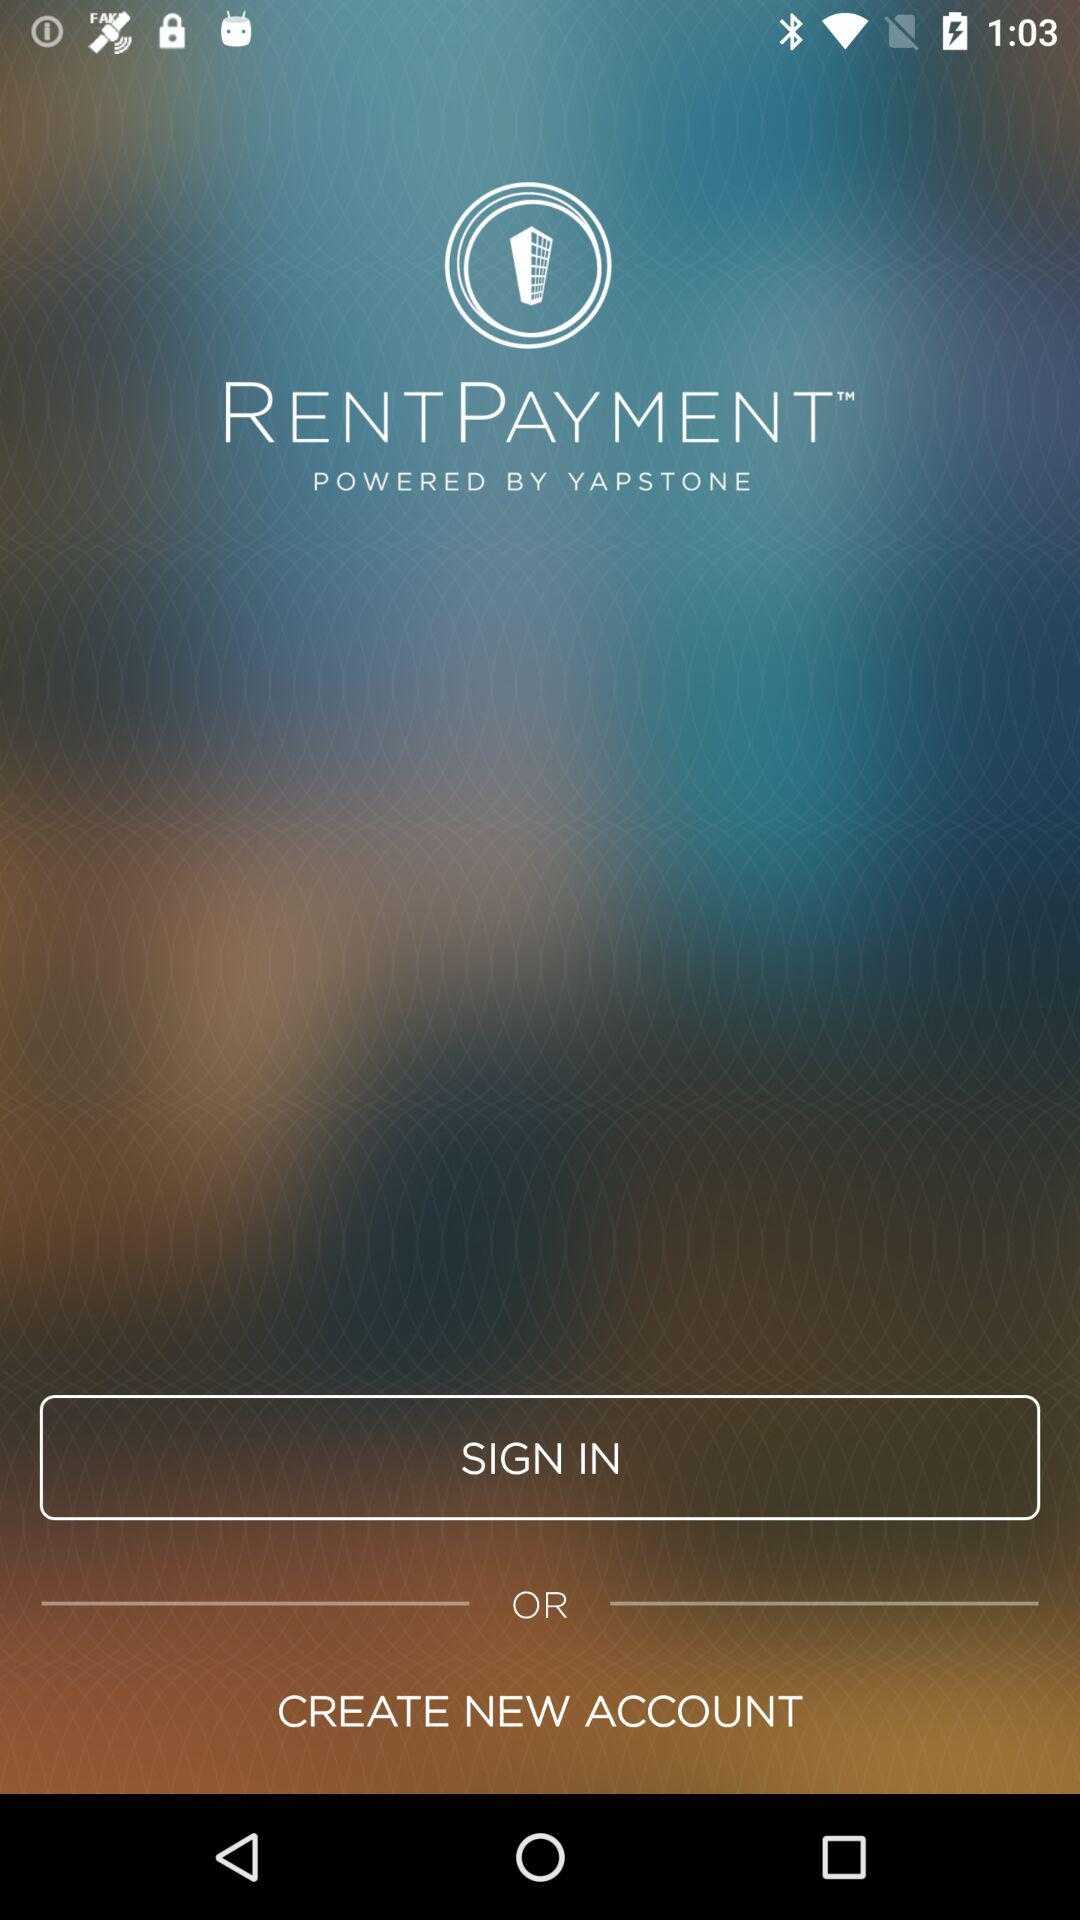What is the application name? The application name is "RENT PAYMENT". 